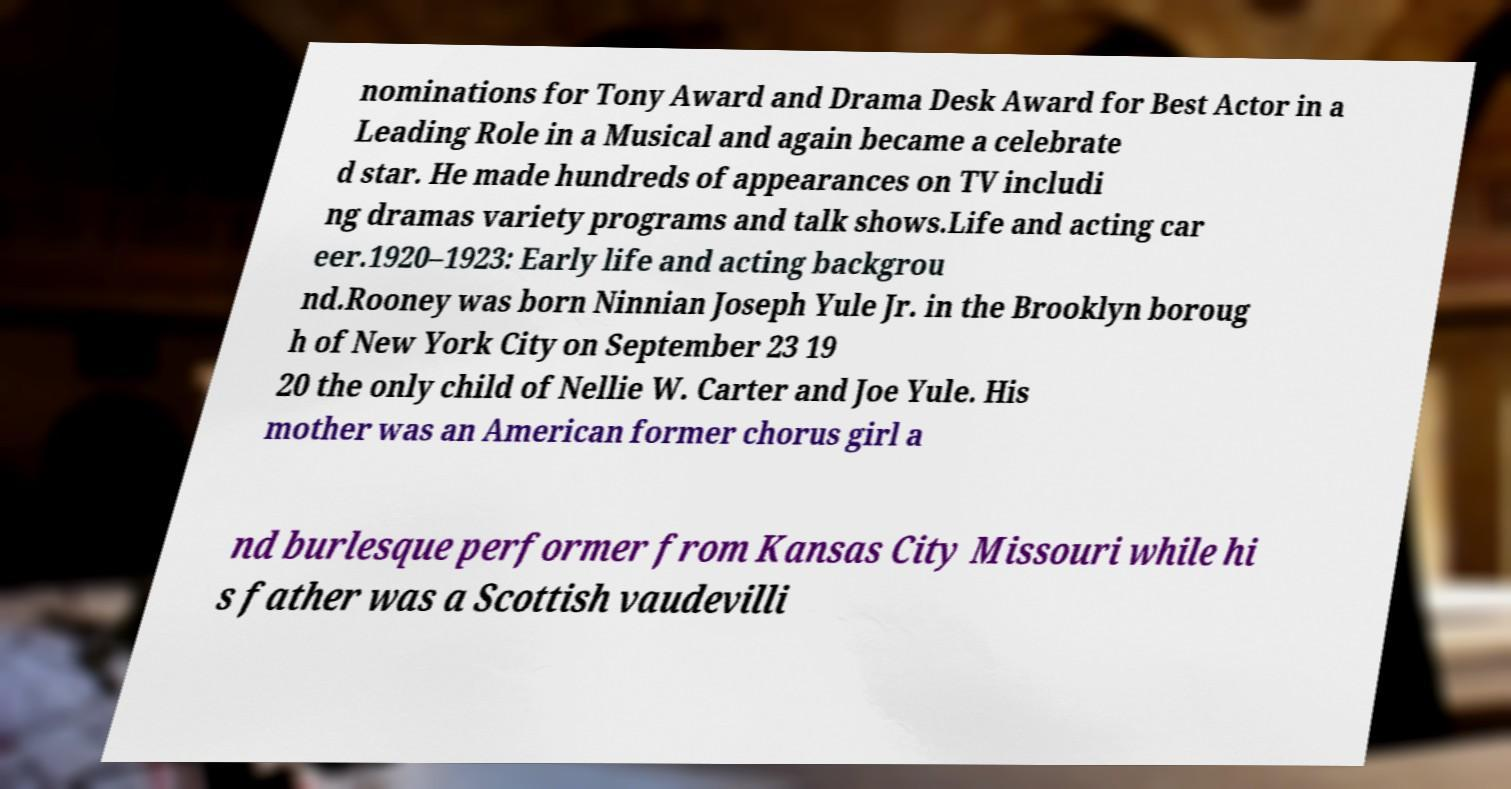Can you read and provide the text displayed in the image?This photo seems to have some interesting text. Can you extract and type it out for me? nominations for Tony Award and Drama Desk Award for Best Actor in a Leading Role in a Musical and again became a celebrate d star. He made hundreds of appearances on TV includi ng dramas variety programs and talk shows.Life and acting car eer.1920–1923: Early life and acting backgrou nd.Rooney was born Ninnian Joseph Yule Jr. in the Brooklyn boroug h of New York City on September 23 19 20 the only child of Nellie W. Carter and Joe Yule. His mother was an American former chorus girl a nd burlesque performer from Kansas City Missouri while hi s father was a Scottish vaudevilli 